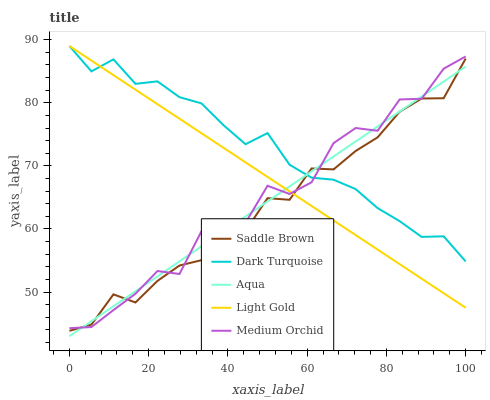Does Saddle Brown have the minimum area under the curve?
Answer yes or no. Yes. Does Dark Turquoise have the maximum area under the curve?
Answer yes or no. Yes. Does Medium Orchid have the minimum area under the curve?
Answer yes or no. No. Does Medium Orchid have the maximum area under the curve?
Answer yes or no. No. Is Light Gold the smoothest?
Answer yes or no. Yes. Is Medium Orchid the roughest?
Answer yes or no. Yes. Is Medium Orchid the smoothest?
Answer yes or no. No. Is Light Gold the roughest?
Answer yes or no. No. Does Aqua have the lowest value?
Answer yes or no. Yes. Does Medium Orchid have the lowest value?
Answer yes or no. No. Does Light Gold have the highest value?
Answer yes or no. Yes. Does Medium Orchid have the highest value?
Answer yes or no. No. Does Aqua intersect Light Gold?
Answer yes or no. Yes. Is Aqua less than Light Gold?
Answer yes or no. No. Is Aqua greater than Light Gold?
Answer yes or no. No. 